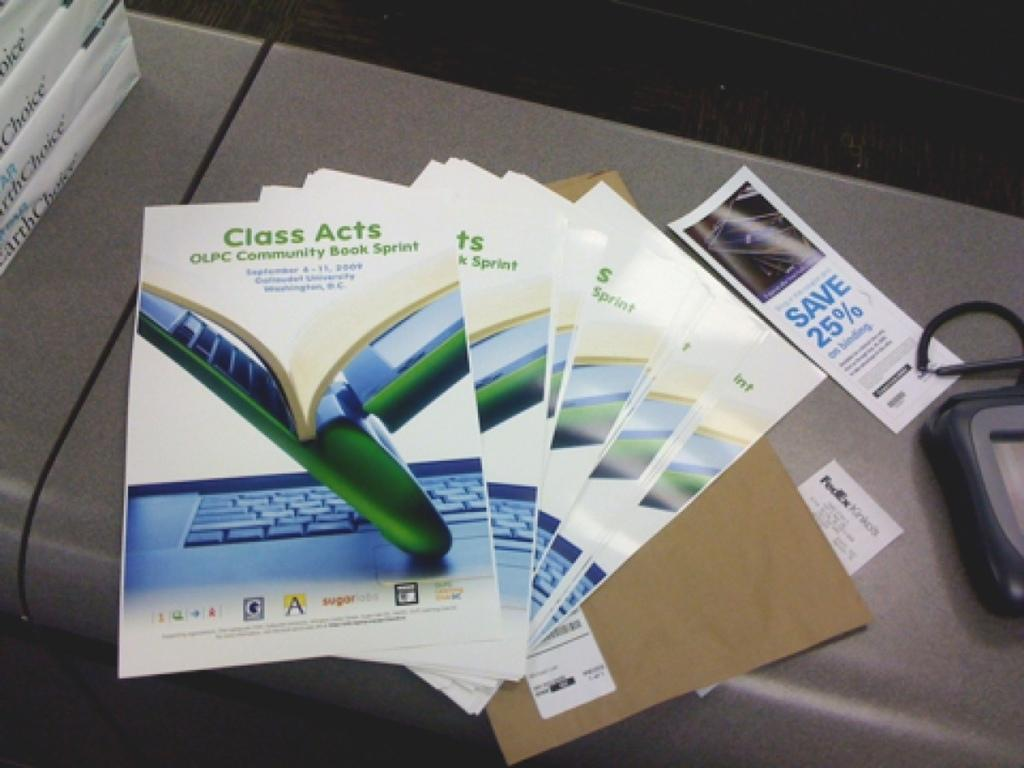<image>
Write a terse but informative summary of the picture. a desk with several brouchures that say Class Acts olpc community bank sprint 